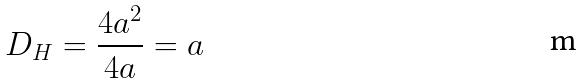Convert formula to latex. <formula><loc_0><loc_0><loc_500><loc_500>D _ { H } = \frac { 4 a ^ { 2 } } { 4 a } = a</formula> 